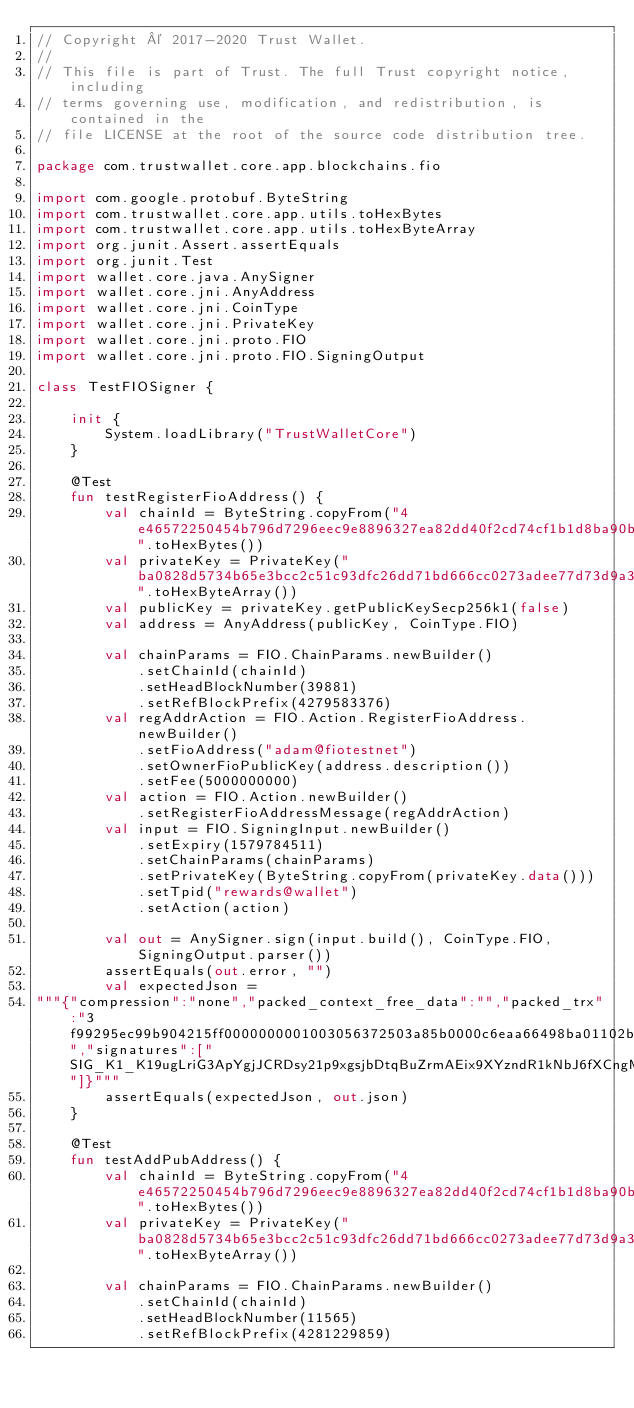<code> <loc_0><loc_0><loc_500><loc_500><_Kotlin_>// Copyright © 2017-2020 Trust Wallet.
//
// This file is part of Trust. The full Trust copyright notice, including
// terms governing use, modification, and redistribution, is contained in the
// file LICENSE at the root of the source code distribution tree.

package com.trustwallet.core.app.blockchains.fio

import com.google.protobuf.ByteString
import com.trustwallet.core.app.utils.toHexBytes
import com.trustwallet.core.app.utils.toHexByteArray
import org.junit.Assert.assertEquals
import org.junit.Test
import wallet.core.java.AnySigner
import wallet.core.jni.AnyAddress
import wallet.core.jni.CoinType
import wallet.core.jni.PrivateKey
import wallet.core.jni.proto.FIO
import wallet.core.jni.proto.FIO.SigningOutput

class TestFIOSigner {

    init {
        System.loadLibrary("TrustWalletCore")
    }

    @Test
    fun testRegisterFioAddress() {
        val chainId = ByteString.copyFrom("4e46572250454b796d7296eec9e8896327ea82dd40f2cd74cf1b1d8ba90bcd77".toHexBytes())
        val privateKey = PrivateKey("ba0828d5734b65e3bcc2c51c93dfc26dd71bd666cc0273adee77d73d9a322035".toHexByteArray())
        val publicKey = privateKey.getPublicKeySecp256k1(false)
        val address = AnyAddress(publicKey, CoinType.FIO)

        val chainParams = FIO.ChainParams.newBuilder()
            .setChainId(chainId)
            .setHeadBlockNumber(39881)
            .setRefBlockPrefix(4279583376)
        val regAddrAction = FIO.Action.RegisterFioAddress.newBuilder()
            .setFioAddress("adam@fiotestnet")
            .setOwnerFioPublicKey(address.description())
            .setFee(5000000000)
        val action = FIO.Action.newBuilder()
            .setRegisterFioAddressMessage(regAddrAction)
        val input = FIO.SigningInput.newBuilder()
            .setExpiry(1579784511)
            .setChainParams(chainParams)
            .setPrivateKey(ByteString.copyFrom(privateKey.data()))
            .setTpid("rewards@wallet")
            .setAction(action)

        val out = AnySigner.sign(input.build(), CoinType.FIO, SigningOutput.parser())
        assertEquals(out.error, "")
        val expectedJson =
"""{"compression":"none","packed_context_free_data":"","packed_trx":"3f99295ec99b904215ff0000000001003056372503a85b0000c6eaa66498ba01102b2f46fca756b200000000a8ed3232650f6164616d4066696f746573746e65743546494f366d31664d645470526b52426e6564765973685843784c4669433573755255384b44667838787874587032686e7478706e6600f2052a01000000102b2f46fca756b20e726577617264734077616c6c657400","signatures":["SIG_K1_K19ugLriG3ApYgjJCRDsy21p9xgsjbDtqBuZrmAEix9XYzndR1kNbJ6fXCngMJMAhxUHfwHAsPnh58otXiJZkazaM1EkS5"]}"""
        assertEquals(expectedJson, out.json)
    }

    @Test
    fun testAddPubAddress() {
        val chainId = ByteString.copyFrom("4e46572250454b796d7296eec9e8896327ea82dd40f2cd74cf1b1d8ba90bcd77".toHexBytes())
        val privateKey = PrivateKey("ba0828d5734b65e3bcc2c51c93dfc26dd71bd666cc0273adee77d73d9a322035".toHexByteArray())

        val chainParams = FIO.ChainParams.newBuilder()
            .setChainId(chainId)
            .setHeadBlockNumber(11565)
            .setRefBlockPrefix(4281229859)</code> 